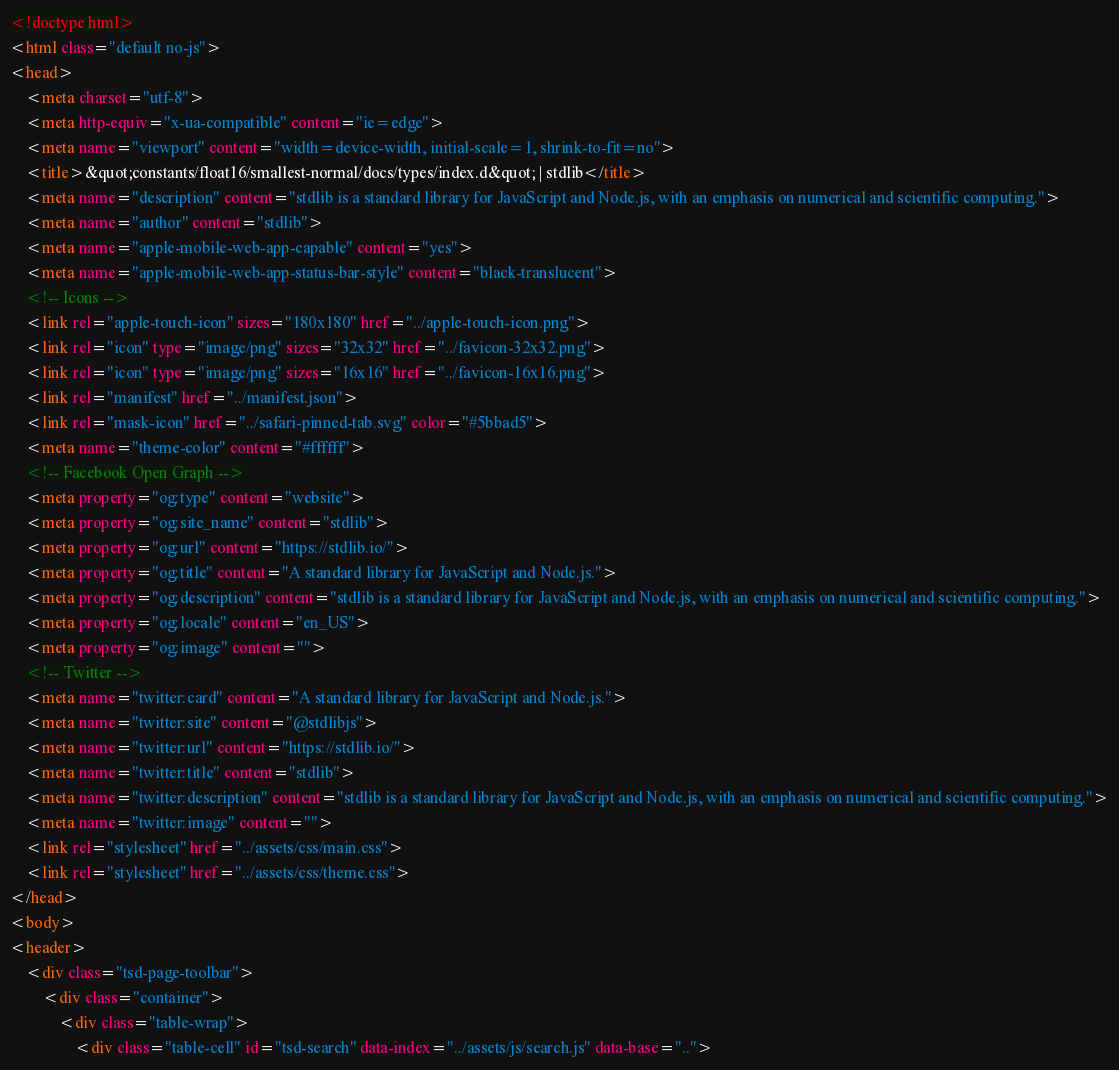<code> <loc_0><loc_0><loc_500><loc_500><_HTML_><!doctype html>
<html class="default no-js">
<head>
	<meta charset="utf-8">
	<meta http-equiv="x-ua-compatible" content="ie=edge">
	<meta name="viewport" content="width=device-width, initial-scale=1, shrink-to-fit=no">
	<title>&quot;constants/float16/smallest-normal/docs/types/index.d&quot; | stdlib</title>
	<meta name="description" content="stdlib is a standard library for JavaScript and Node.js, with an emphasis on numerical and scientific computing.">
	<meta name="author" content="stdlib">
	<meta name="apple-mobile-web-app-capable" content="yes">
	<meta name="apple-mobile-web-app-status-bar-style" content="black-translucent">
	<!-- Icons -->
	<link rel="apple-touch-icon" sizes="180x180" href="../apple-touch-icon.png">
	<link rel="icon" type="image/png" sizes="32x32" href="../favicon-32x32.png">
	<link rel="icon" type="image/png" sizes="16x16" href="../favicon-16x16.png">
	<link rel="manifest" href="../manifest.json">
	<link rel="mask-icon" href="../safari-pinned-tab.svg" color="#5bbad5">
	<meta name="theme-color" content="#ffffff">
	<!-- Facebook Open Graph -->
	<meta property="og:type" content="website">
	<meta property="og:site_name" content="stdlib">
	<meta property="og:url" content="https://stdlib.io/">
	<meta property="og:title" content="A standard library for JavaScript and Node.js.">
	<meta property="og:description" content="stdlib is a standard library for JavaScript and Node.js, with an emphasis on numerical and scientific computing.">
	<meta property="og:locale" content="en_US">
	<meta property="og:image" content="">
	<!-- Twitter -->
	<meta name="twitter:card" content="A standard library for JavaScript and Node.js.">
	<meta name="twitter:site" content="@stdlibjs">
	<meta name="twitter:url" content="https://stdlib.io/">
	<meta name="twitter:title" content="stdlib">
	<meta name="twitter:description" content="stdlib is a standard library for JavaScript and Node.js, with an emphasis on numerical and scientific computing.">
	<meta name="twitter:image" content="">
	<link rel="stylesheet" href="../assets/css/main.css">
	<link rel="stylesheet" href="../assets/css/theme.css">
</head>
<body>
<header>
	<div class="tsd-page-toolbar">
		<div class="container">
			<div class="table-wrap">
				<div class="table-cell" id="tsd-search" data-index="../assets/js/search.js" data-base=".."></code> 